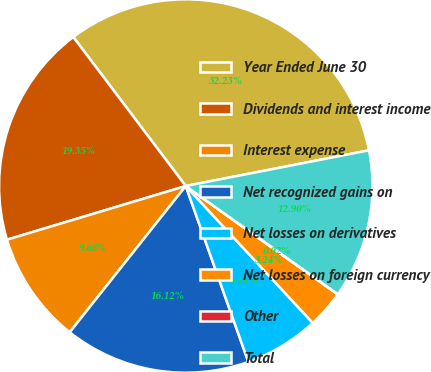Convert chart. <chart><loc_0><loc_0><loc_500><loc_500><pie_chart><fcel>Year Ended June 30<fcel>Dividends and interest income<fcel>Interest expense<fcel>Net recognized gains on<fcel>Net losses on derivatives<fcel>Net losses on foreign currency<fcel>Other<fcel>Total<nl><fcel>32.23%<fcel>19.35%<fcel>9.68%<fcel>16.12%<fcel>6.46%<fcel>3.24%<fcel>0.02%<fcel>12.9%<nl></chart> 